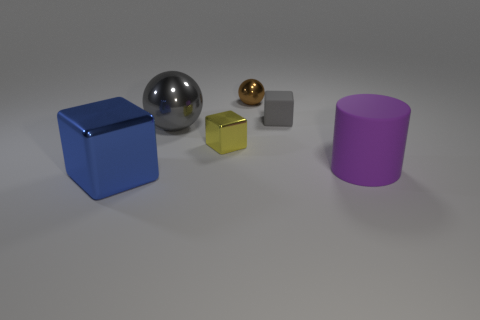Subtract all rubber blocks. How many blocks are left? 2 Subtract all spheres. How many objects are left? 4 Subtract all blue cubes. How many cubes are left? 2 Add 4 yellow metallic things. How many objects exist? 10 Subtract 3 cubes. How many cubes are left? 0 Subtract all yellow cylinders. Subtract all red blocks. How many cylinders are left? 1 Subtract all yellow cylinders. How many gray spheres are left? 1 Subtract all tiny brown metallic objects. Subtract all tiny green spheres. How many objects are left? 5 Add 3 gray metal objects. How many gray metal objects are left? 4 Add 2 large cyan rubber balls. How many large cyan rubber balls exist? 2 